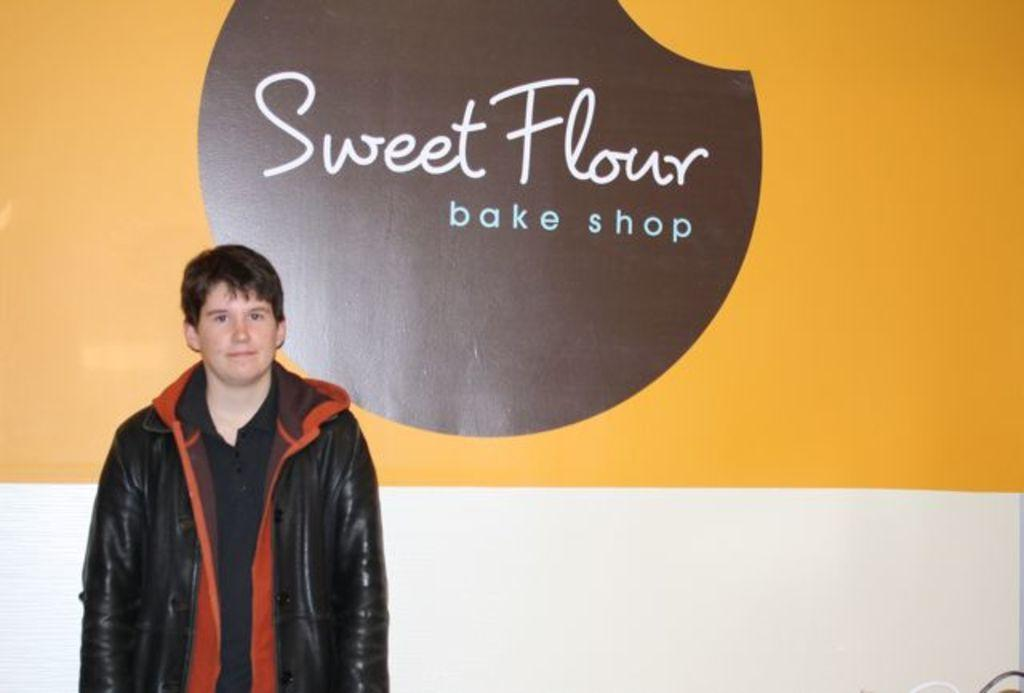What is the main subject of the image? There is a person in the image. What is the person wearing? The person is wearing a black jacket. Where is the person standing in relation to the wall? The person is standing near a wall. Can you describe the colors of the wall? The wall has white, yellow, and brown colors. What is written on the wall? There is text written on the wall. How much rain does the nation receive during the rainstorm depicted in the image? There is no rainstorm depicted in the image, and no nation is mentioned. 